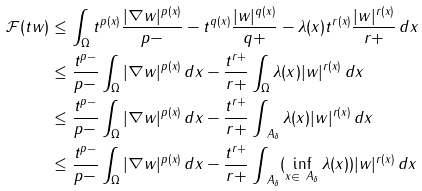Convert formula to latex. <formula><loc_0><loc_0><loc_500><loc_500>\mathcal { F } ( t w ) & \leq \int _ { \Omega } t ^ { p ( x ) } \frac { | \nabla w | ^ { p ( x ) } } { p - } - t ^ { q ( x ) } \frac { | w | ^ { q ( x ) } } { q + } - \lambda ( x ) t ^ { r ( x ) } \frac { | w | ^ { r ( x ) } } { r + } \, d x \\ & \leq \frac { t ^ { p - } } { p - } \int _ { \Omega } | \nabla w | ^ { p ( x ) } \, d x - \frac { t ^ { r + } } { r + } \int _ { \Omega } \lambda ( x ) | w | ^ { r ( x ) } \, d x \\ & \leq \frac { t ^ { p - } } { p - } \int _ { \Omega } | \nabla w | ^ { p ( x ) } \, d x - \frac { t ^ { r + } } { r + } \int _ { \ A _ { \delta } } \lambda ( x ) | w | ^ { r ( x ) } \, d x \\ & \leq \frac { t ^ { p - } } { p - } \int _ { \Omega } | \nabla w | ^ { p ( x ) } \, d x - \frac { t ^ { r + } } { r + } \int _ { \ A _ { \delta } } ( \inf _ { x \in \ A _ { \delta } } \lambda ( x ) ) | w | ^ { r ( x ) } \, d x</formula> 